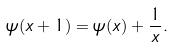<formula> <loc_0><loc_0><loc_500><loc_500>\psi ( x + 1 ) = \psi ( x ) + \frac { 1 } { x } .</formula> 